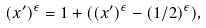<formula> <loc_0><loc_0><loc_500><loc_500>( x ^ { \prime } ) ^ { \epsilon } = 1 + ( ( x ^ { \prime } ) ^ { \epsilon } - ( 1 / 2 ) ^ { \epsilon } ) ,</formula> 